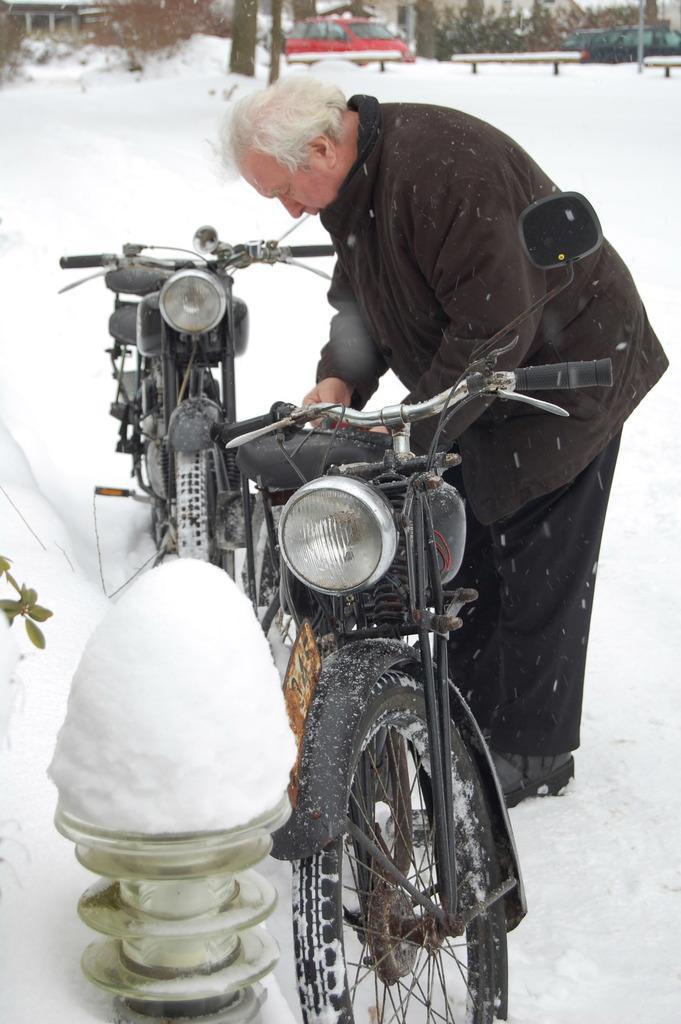In one or two sentences, can you explain what this image depicts? In this picture there is snow everywhere. In the foreground of the picture there are motorbikes, light, a person wearing a thick jacket and plant. In the background there are cars, trees, railing, buildings. 